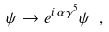<formula> <loc_0><loc_0><loc_500><loc_500>\psi \to e ^ { i \alpha \gamma ^ { 5 } } \psi \ ,</formula> 